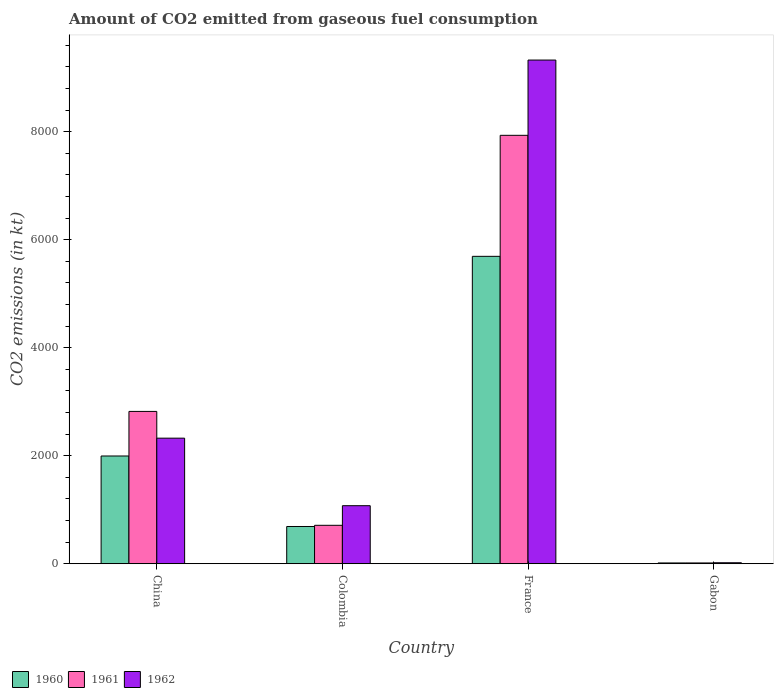Are the number of bars on each tick of the X-axis equal?
Offer a terse response. Yes. How many bars are there on the 1st tick from the left?
Ensure brevity in your answer.  3. What is the label of the 2nd group of bars from the left?
Offer a very short reply. Colombia. In how many cases, is the number of bars for a given country not equal to the number of legend labels?
Provide a succinct answer. 0. What is the amount of CO2 emitted in 1960 in France?
Make the answer very short. 5691.18. Across all countries, what is the maximum amount of CO2 emitted in 1961?
Your answer should be compact. 7931.72. Across all countries, what is the minimum amount of CO2 emitted in 1962?
Your response must be concise. 18.34. In which country was the amount of CO2 emitted in 1961 maximum?
Your response must be concise. France. In which country was the amount of CO2 emitted in 1961 minimum?
Provide a succinct answer. Gabon. What is the total amount of CO2 emitted in 1962 in the graph?
Offer a very short reply. 1.27e+04. What is the difference between the amount of CO2 emitted in 1962 in France and that in Gabon?
Keep it short and to the point. 9306.85. What is the difference between the amount of CO2 emitted in 1962 in Gabon and the amount of CO2 emitted in 1961 in France?
Keep it short and to the point. -7913.39. What is the average amount of CO2 emitted in 1962 per country?
Keep it short and to the point. 3185.71. What is the difference between the amount of CO2 emitted of/in 1960 and amount of CO2 emitted of/in 1961 in Gabon?
Offer a terse response. 0. What is the ratio of the amount of CO2 emitted in 1962 in Colombia to that in Gabon?
Make the answer very short. 58.6. Is the difference between the amount of CO2 emitted in 1960 in France and Gabon greater than the difference between the amount of CO2 emitted in 1961 in France and Gabon?
Keep it short and to the point. No. What is the difference between the highest and the second highest amount of CO2 emitted in 1962?
Your answer should be compact. -1250.45. What is the difference between the highest and the lowest amount of CO2 emitted in 1960?
Your answer should be compact. 5676.52. Is the sum of the amount of CO2 emitted in 1960 in Colombia and Gabon greater than the maximum amount of CO2 emitted in 1962 across all countries?
Your answer should be compact. No. What does the 3rd bar from the left in China represents?
Offer a very short reply. 1962. How many bars are there?
Provide a succinct answer. 12. Does the graph contain any zero values?
Ensure brevity in your answer.  No. Does the graph contain grids?
Give a very brief answer. No. Where does the legend appear in the graph?
Keep it short and to the point. Bottom left. What is the title of the graph?
Your answer should be very brief. Amount of CO2 emitted from gaseous fuel consumption. Does "1988" appear as one of the legend labels in the graph?
Keep it short and to the point. No. What is the label or title of the Y-axis?
Your answer should be compact. CO2 emissions (in kt). What is the CO2 emissions (in kt) in 1960 in China?
Keep it short and to the point. 1994.85. What is the CO2 emissions (in kt) in 1961 in China?
Provide a short and direct response. 2819.92. What is the CO2 emissions (in kt) in 1962 in China?
Your response must be concise. 2324.88. What is the CO2 emissions (in kt) of 1960 in Colombia?
Provide a short and direct response. 689.4. What is the CO2 emissions (in kt) in 1961 in Colombia?
Offer a very short reply. 711.4. What is the CO2 emissions (in kt) of 1962 in Colombia?
Provide a short and direct response. 1074.43. What is the CO2 emissions (in kt) in 1960 in France?
Offer a very short reply. 5691.18. What is the CO2 emissions (in kt) of 1961 in France?
Offer a terse response. 7931.72. What is the CO2 emissions (in kt) of 1962 in France?
Keep it short and to the point. 9325.18. What is the CO2 emissions (in kt) of 1960 in Gabon?
Offer a very short reply. 14.67. What is the CO2 emissions (in kt) in 1961 in Gabon?
Provide a succinct answer. 14.67. What is the CO2 emissions (in kt) of 1962 in Gabon?
Your answer should be very brief. 18.34. Across all countries, what is the maximum CO2 emissions (in kt) in 1960?
Make the answer very short. 5691.18. Across all countries, what is the maximum CO2 emissions (in kt) in 1961?
Provide a succinct answer. 7931.72. Across all countries, what is the maximum CO2 emissions (in kt) in 1962?
Your answer should be very brief. 9325.18. Across all countries, what is the minimum CO2 emissions (in kt) of 1960?
Offer a very short reply. 14.67. Across all countries, what is the minimum CO2 emissions (in kt) of 1961?
Your response must be concise. 14.67. Across all countries, what is the minimum CO2 emissions (in kt) in 1962?
Your response must be concise. 18.34. What is the total CO2 emissions (in kt) in 1960 in the graph?
Provide a succinct answer. 8390.1. What is the total CO2 emissions (in kt) in 1961 in the graph?
Your response must be concise. 1.15e+04. What is the total CO2 emissions (in kt) of 1962 in the graph?
Your answer should be very brief. 1.27e+04. What is the difference between the CO2 emissions (in kt) in 1960 in China and that in Colombia?
Give a very brief answer. 1305.45. What is the difference between the CO2 emissions (in kt) in 1961 in China and that in Colombia?
Provide a short and direct response. 2108.53. What is the difference between the CO2 emissions (in kt) of 1962 in China and that in Colombia?
Make the answer very short. 1250.45. What is the difference between the CO2 emissions (in kt) in 1960 in China and that in France?
Your answer should be very brief. -3696.34. What is the difference between the CO2 emissions (in kt) of 1961 in China and that in France?
Your answer should be compact. -5111.8. What is the difference between the CO2 emissions (in kt) of 1962 in China and that in France?
Your answer should be very brief. -7000.3. What is the difference between the CO2 emissions (in kt) in 1960 in China and that in Gabon?
Make the answer very short. 1980.18. What is the difference between the CO2 emissions (in kt) of 1961 in China and that in Gabon?
Your answer should be compact. 2805.26. What is the difference between the CO2 emissions (in kt) in 1962 in China and that in Gabon?
Offer a terse response. 2306.54. What is the difference between the CO2 emissions (in kt) of 1960 in Colombia and that in France?
Offer a very short reply. -5001.79. What is the difference between the CO2 emissions (in kt) in 1961 in Colombia and that in France?
Offer a very short reply. -7220.32. What is the difference between the CO2 emissions (in kt) of 1962 in Colombia and that in France?
Ensure brevity in your answer.  -8250.75. What is the difference between the CO2 emissions (in kt) of 1960 in Colombia and that in Gabon?
Offer a very short reply. 674.73. What is the difference between the CO2 emissions (in kt) in 1961 in Colombia and that in Gabon?
Offer a terse response. 696.73. What is the difference between the CO2 emissions (in kt) of 1962 in Colombia and that in Gabon?
Make the answer very short. 1056.1. What is the difference between the CO2 emissions (in kt) in 1960 in France and that in Gabon?
Ensure brevity in your answer.  5676.52. What is the difference between the CO2 emissions (in kt) in 1961 in France and that in Gabon?
Your response must be concise. 7917.05. What is the difference between the CO2 emissions (in kt) in 1962 in France and that in Gabon?
Ensure brevity in your answer.  9306.85. What is the difference between the CO2 emissions (in kt) of 1960 in China and the CO2 emissions (in kt) of 1961 in Colombia?
Your answer should be very brief. 1283.45. What is the difference between the CO2 emissions (in kt) in 1960 in China and the CO2 emissions (in kt) in 1962 in Colombia?
Your response must be concise. 920.42. What is the difference between the CO2 emissions (in kt) in 1961 in China and the CO2 emissions (in kt) in 1962 in Colombia?
Your response must be concise. 1745.49. What is the difference between the CO2 emissions (in kt) in 1960 in China and the CO2 emissions (in kt) in 1961 in France?
Ensure brevity in your answer.  -5936.87. What is the difference between the CO2 emissions (in kt) of 1960 in China and the CO2 emissions (in kt) of 1962 in France?
Your answer should be compact. -7330.33. What is the difference between the CO2 emissions (in kt) in 1961 in China and the CO2 emissions (in kt) in 1962 in France?
Your response must be concise. -6505.26. What is the difference between the CO2 emissions (in kt) in 1960 in China and the CO2 emissions (in kt) in 1961 in Gabon?
Make the answer very short. 1980.18. What is the difference between the CO2 emissions (in kt) in 1960 in China and the CO2 emissions (in kt) in 1962 in Gabon?
Make the answer very short. 1976.51. What is the difference between the CO2 emissions (in kt) of 1961 in China and the CO2 emissions (in kt) of 1962 in Gabon?
Your response must be concise. 2801.59. What is the difference between the CO2 emissions (in kt) of 1960 in Colombia and the CO2 emissions (in kt) of 1961 in France?
Offer a terse response. -7242.32. What is the difference between the CO2 emissions (in kt) in 1960 in Colombia and the CO2 emissions (in kt) in 1962 in France?
Provide a succinct answer. -8635.78. What is the difference between the CO2 emissions (in kt) of 1961 in Colombia and the CO2 emissions (in kt) of 1962 in France?
Provide a succinct answer. -8613.78. What is the difference between the CO2 emissions (in kt) of 1960 in Colombia and the CO2 emissions (in kt) of 1961 in Gabon?
Ensure brevity in your answer.  674.73. What is the difference between the CO2 emissions (in kt) of 1960 in Colombia and the CO2 emissions (in kt) of 1962 in Gabon?
Give a very brief answer. 671.06. What is the difference between the CO2 emissions (in kt) in 1961 in Colombia and the CO2 emissions (in kt) in 1962 in Gabon?
Give a very brief answer. 693.06. What is the difference between the CO2 emissions (in kt) of 1960 in France and the CO2 emissions (in kt) of 1961 in Gabon?
Provide a succinct answer. 5676.52. What is the difference between the CO2 emissions (in kt) of 1960 in France and the CO2 emissions (in kt) of 1962 in Gabon?
Offer a very short reply. 5672.85. What is the difference between the CO2 emissions (in kt) in 1961 in France and the CO2 emissions (in kt) in 1962 in Gabon?
Keep it short and to the point. 7913.39. What is the average CO2 emissions (in kt) of 1960 per country?
Offer a terse response. 2097.52. What is the average CO2 emissions (in kt) of 1961 per country?
Make the answer very short. 2869.43. What is the average CO2 emissions (in kt) of 1962 per country?
Offer a very short reply. 3185.71. What is the difference between the CO2 emissions (in kt) in 1960 and CO2 emissions (in kt) in 1961 in China?
Ensure brevity in your answer.  -825.08. What is the difference between the CO2 emissions (in kt) in 1960 and CO2 emissions (in kt) in 1962 in China?
Offer a terse response. -330.03. What is the difference between the CO2 emissions (in kt) of 1961 and CO2 emissions (in kt) of 1962 in China?
Give a very brief answer. 495.05. What is the difference between the CO2 emissions (in kt) of 1960 and CO2 emissions (in kt) of 1961 in Colombia?
Your answer should be very brief. -22. What is the difference between the CO2 emissions (in kt) in 1960 and CO2 emissions (in kt) in 1962 in Colombia?
Provide a short and direct response. -385.04. What is the difference between the CO2 emissions (in kt) in 1961 and CO2 emissions (in kt) in 1962 in Colombia?
Your answer should be compact. -363.03. What is the difference between the CO2 emissions (in kt) in 1960 and CO2 emissions (in kt) in 1961 in France?
Your response must be concise. -2240.54. What is the difference between the CO2 emissions (in kt) of 1960 and CO2 emissions (in kt) of 1962 in France?
Your answer should be very brief. -3634. What is the difference between the CO2 emissions (in kt) of 1961 and CO2 emissions (in kt) of 1962 in France?
Ensure brevity in your answer.  -1393.46. What is the difference between the CO2 emissions (in kt) in 1960 and CO2 emissions (in kt) in 1961 in Gabon?
Give a very brief answer. 0. What is the difference between the CO2 emissions (in kt) in 1960 and CO2 emissions (in kt) in 1962 in Gabon?
Ensure brevity in your answer.  -3.67. What is the difference between the CO2 emissions (in kt) in 1961 and CO2 emissions (in kt) in 1962 in Gabon?
Give a very brief answer. -3.67. What is the ratio of the CO2 emissions (in kt) of 1960 in China to that in Colombia?
Your answer should be very brief. 2.89. What is the ratio of the CO2 emissions (in kt) of 1961 in China to that in Colombia?
Provide a short and direct response. 3.96. What is the ratio of the CO2 emissions (in kt) of 1962 in China to that in Colombia?
Offer a very short reply. 2.16. What is the ratio of the CO2 emissions (in kt) of 1960 in China to that in France?
Your response must be concise. 0.35. What is the ratio of the CO2 emissions (in kt) of 1961 in China to that in France?
Provide a succinct answer. 0.36. What is the ratio of the CO2 emissions (in kt) in 1962 in China to that in France?
Keep it short and to the point. 0.25. What is the ratio of the CO2 emissions (in kt) of 1960 in China to that in Gabon?
Provide a succinct answer. 136. What is the ratio of the CO2 emissions (in kt) in 1961 in China to that in Gabon?
Provide a succinct answer. 192.25. What is the ratio of the CO2 emissions (in kt) of 1962 in China to that in Gabon?
Provide a succinct answer. 126.8. What is the ratio of the CO2 emissions (in kt) in 1960 in Colombia to that in France?
Offer a very short reply. 0.12. What is the ratio of the CO2 emissions (in kt) in 1961 in Colombia to that in France?
Your answer should be compact. 0.09. What is the ratio of the CO2 emissions (in kt) of 1962 in Colombia to that in France?
Make the answer very short. 0.12. What is the ratio of the CO2 emissions (in kt) of 1960 in Colombia to that in Gabon?
Your answer should be very brief. 47. What is the ratio of the CO2 emissions (in kt) of 1961 in Colombia to that in Gabon?
Make the answer very short. 48.5. What is the ratio of the CO2 emissions (in kt) in 1962 in Colombia to that in Gabon?
Offer a very short reply. 58.6. What is the ratio of the CO2 emissions (in kt) in 1960 in France to that in Gabon?
Offer a very short reply. 388. What is the ratio of the CO2 emissions (in kt) of 1961 in France to that in Gabon?
Keep it short and to the point. 540.75. What is the ratio of the CO2 emissions (in kt) in 1962 in France to that in Gabon?
Your answer should be very brief. 508.6. What is the difference between the highest and the second highest CO2 emissions (in kt) in 1960?
Offer a terse response. 3696.34. What is the difference between the highest and the second highest CO2 emissions (in kt) of 1961?
Make the answer very short. 5111.8. What is the difference between the highest and the second highest CO2 emissions (in kt) of 1962?
Provide a short and direct response. 7000.3. What is the difference between the highest and the lowest CO2 emissions (in kt) in 1960?
Make the answer very short. 5676.52. What is the difference between the highest and the lowest CO2 emissions (in kt) in 1961?
Your response must be concise. 7917.05. What is the difference between the highest and the lowest CO2 emissions (in kt) of 1962?
Offer a very short reply. 9306.85. 